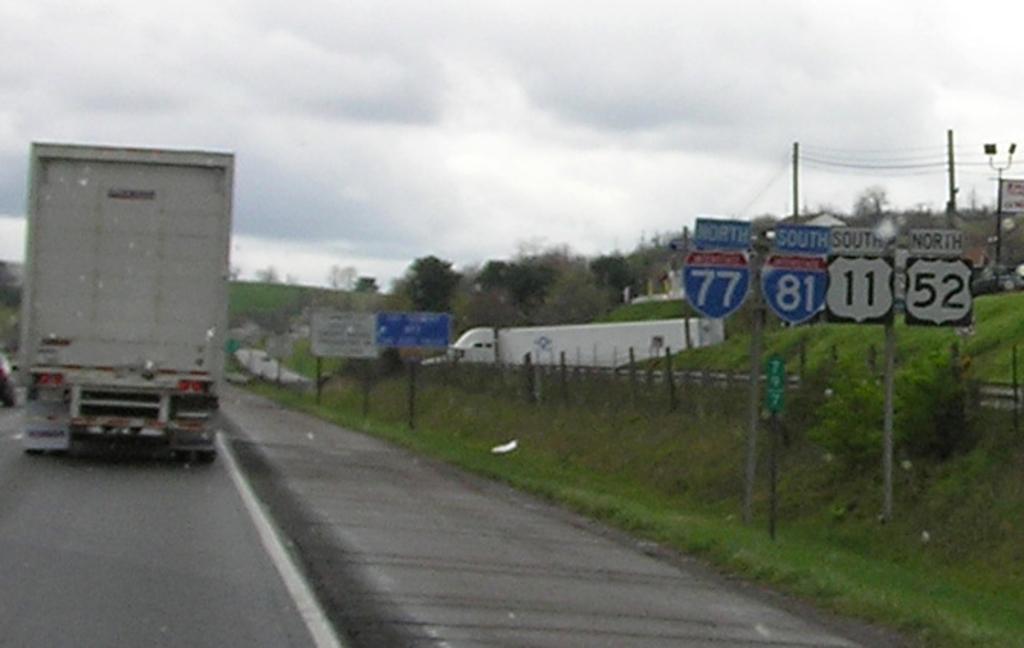Describe this image in one or two sentences. In this picture I can see a vehicle on the road. Here I can see a fence, grass, plants and trees. Here I can see poles which has wires. In the background I can see the sky. 